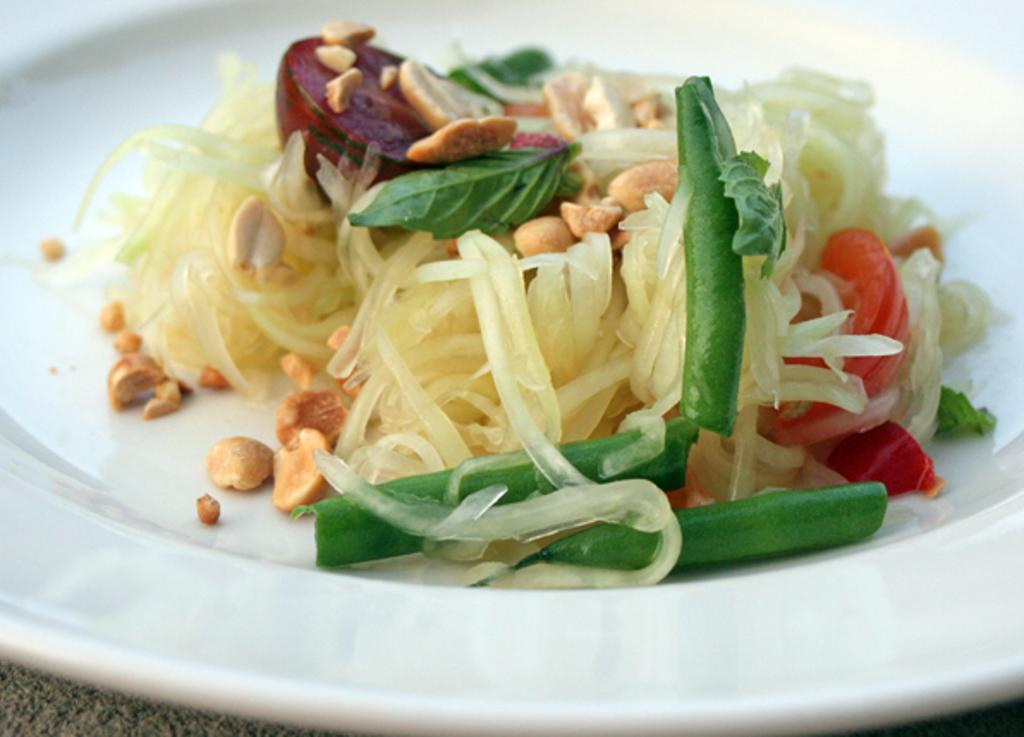What is the main subject of the image? The main subject of the image is a food item on a plate. Can you describe the color of the plate? The plate is white in color. What type of celery is used to cover the scene in the image? There is no celery present in the image, and the term "scene" is not applicable to the image. 